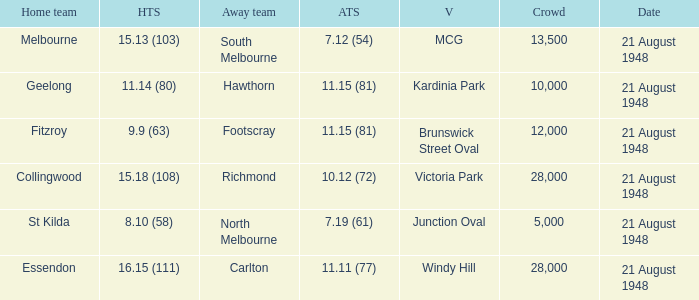When the venue is victoria park, what's the largest Crowd that attended? 28000.0. 